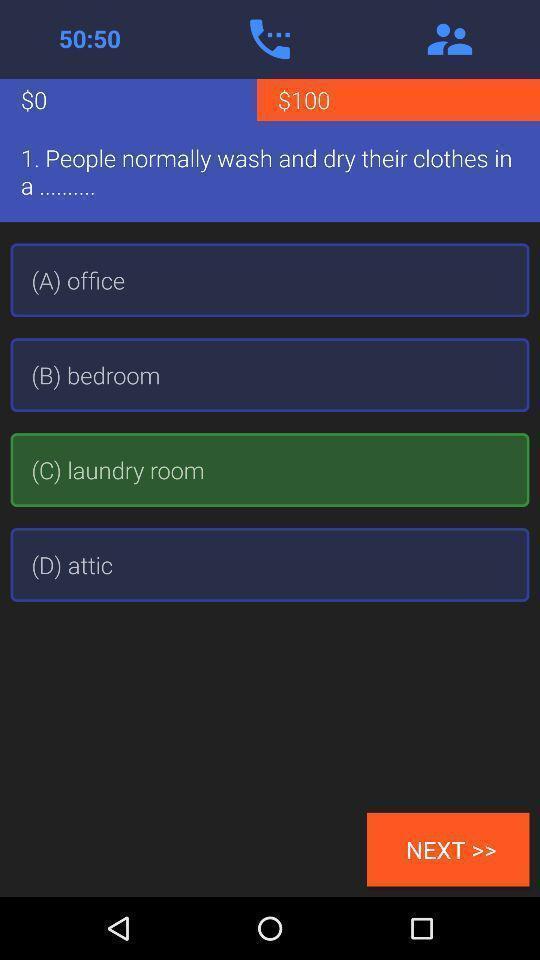Provide a description of this screenshot. Question with a options with time. 